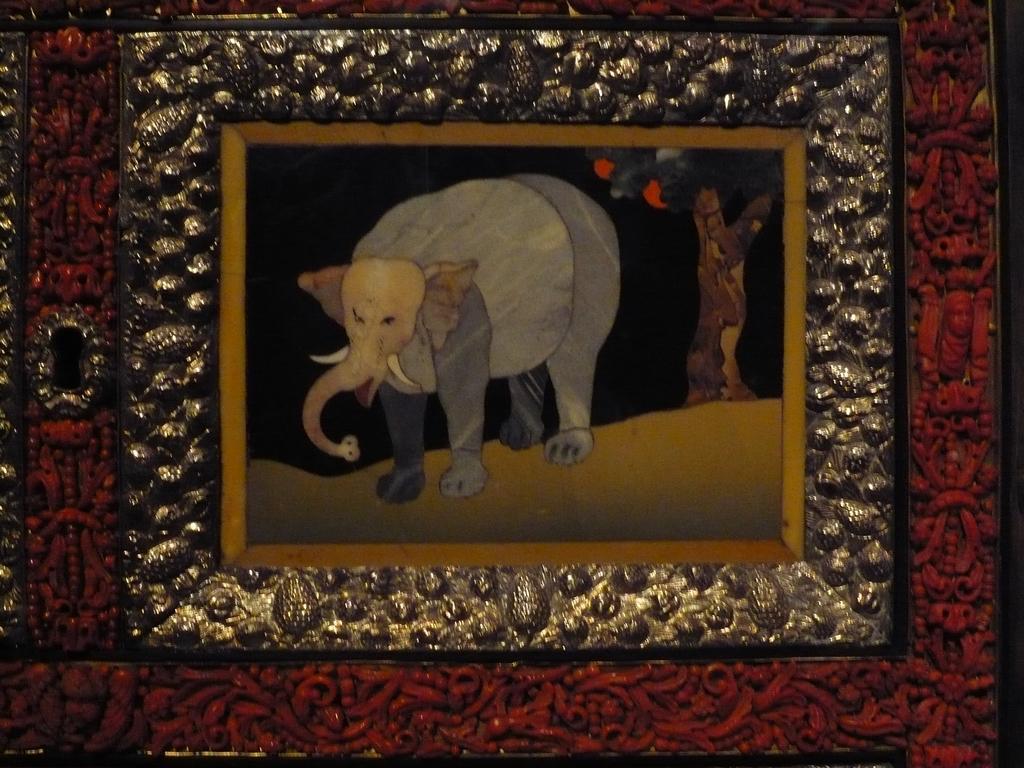How would you summarize this image in a sentence or two? In this picture I can see there is a drawing of a elephant and there is a tree behind the elephant and there are fruits to the tree. This is kept in a photo frame of gold and red color. 